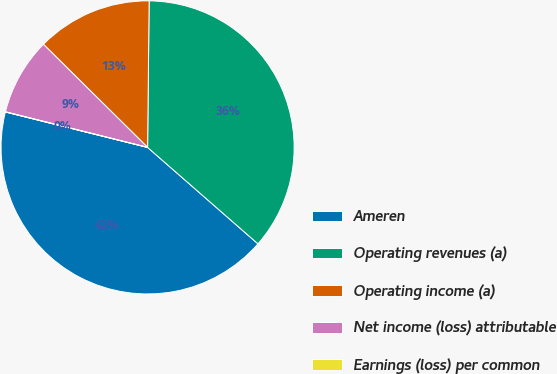Convert chart. <chart><loc_0><loc_0><loc_500><loc_500><pie_chart><fcel>Ameren<fcel>Operating revenues (a)<fcel>Operating income (a)<fcel>Net income (loss) attributable<fcel>Earnings (loss) per common<nl><fcel>42.45%<fcel>36.26%<fcel>12.75%<fcel>8.51%<fcel>0.02%<nl></chart> 